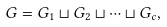Convert formula to latex. <formula><loc_0><loc_0><loc_500><loc_500>G = G _ { 1 } \sqcup G _ { 2 } \sqcup \cdots \sqcup G _ { c } ,</formula> 